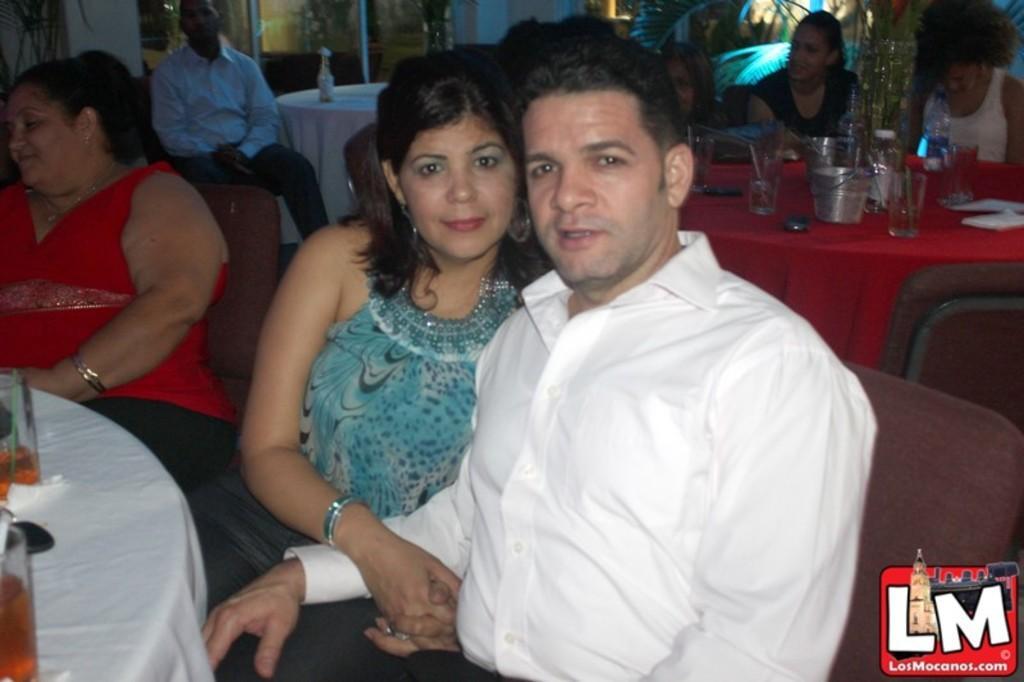Could you give a brief overview of what you see in this image? In this image there are two men sitting, there are five women sitting on the chairs, there are tables, there is cloth on the tables, there are objects on the clothes, there is a glass wall towards the top of the image, there is a wall towards the top of the image, there is a text towards the bottom of the image. 